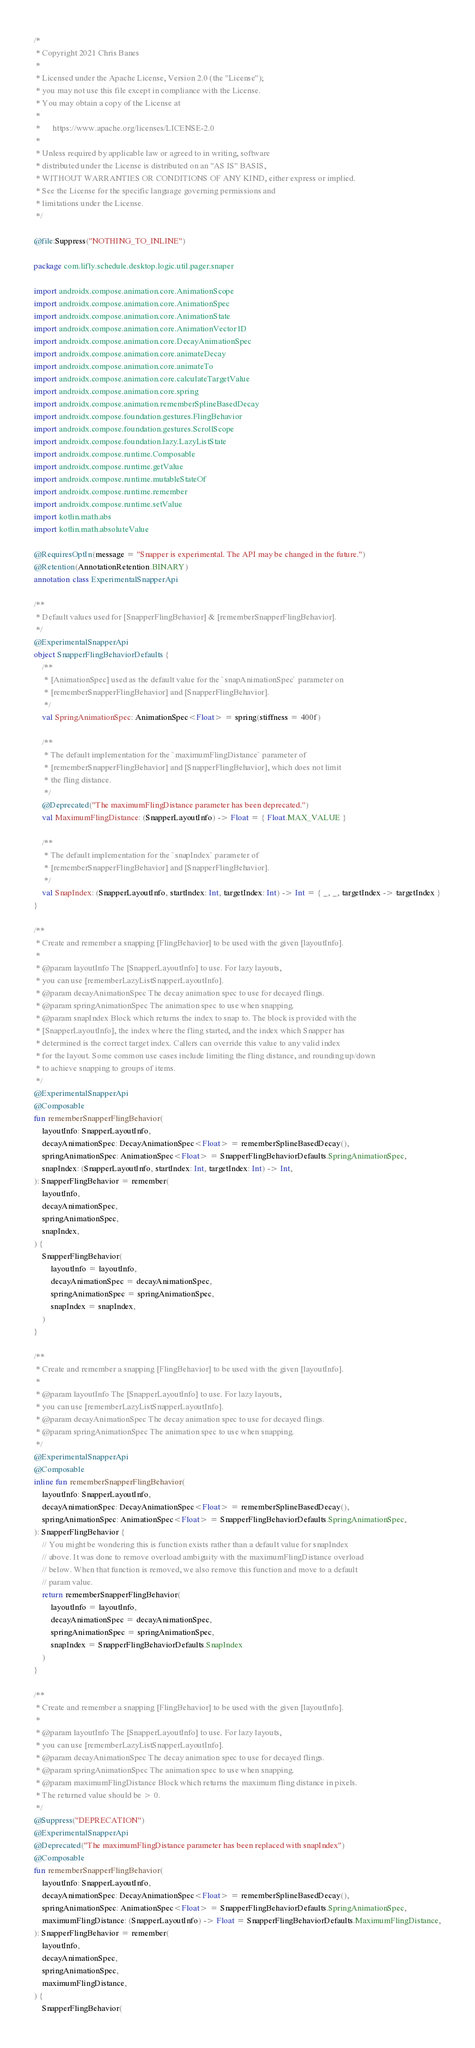Convert code to text. <code><loc_0><loc_0><loc_500><loc_500><_Kotlin_>/*
 * Copyright 2021 Chris Banes
 *
 * Licensed under the Apache License, Version 2.0 (the "License");
 * you may not use this file except in compliance with the License.
 * You may obtain a copy of the License at
 *
 *      https://www.apache.org/licenses/LICENSE-2.0
 *
 * Unless required by applicable law or agreed to in writing, software
 * distributed under the License is distributed on an "AS IS" BASIS,
 * WITHOUT WARRANTIES OR CONDITIONS OF ANY KIND, either express or implied.
 * See the License for the specific language governing permissions and
 * limitations under the License.
 */

@file:Suppress("NOTHING_TO_INLINE")

package com.lifly.schedule.desktop.logic.util.pager.snaper

import androidx.compose.animation.core.AnimationScope
import androidx.compose.animation.core.AnimationSpec
import androidx.compose.animation.core.AnimationState
import androidx.compose.animation.core.AnimationVector1D
import androidx.compose.animation.core.DecayAnimationSpec
import androidx.compose.animation.core.animateDecay
import androidx.compose.animation.core.animateTo
import androidx.compose.animation.core.calculateTargetValue
import androidx.compose.animation.core.spring
import androidx.compose.animation.rememberSplineBasedDecay
import androidx.compose.foundation.gestures.FlingBehavior
import androidx.compose.foundation.gestures.ScrollScope
import androidx.compose.foundation.lazy.LazyListState
import androidx.compose.runtime.Composable
import androidx.compose.runtime.getValue
import androidx.compose.runtime.mutableStateOf
import androidx.compose.runtime.remember
import androidx.compose.runtime.setValue
import kotlin.math.abs
import kotlin.math.absoluteValue

@RequiresOptIn(message = "Snapper is experimental. The API may be changed in the future.")
@Retention(AnnotationRetention.BINARY)
annotation class ExperimentalSnapperApi

/**
 * Default values used for [SnapperFlingBehavior] & [rememberSnapperFlingBehavior].
 */
@ExperimentalSnapperApi
object SnapperFlingBehaviorDefaults {
    /**
     * [AnimationSpec] used as the default value for the `snapAnimationSpec` parameter on
     * [rememberSnapperFlingBehavior] and [SnapperFlingBehavior].
     */
    val SpringAnimationSpec: AnimationSpec<Float> = spring(stiffness = 400f)

    /**
     * The default implementation for the `maximumFlingDistance` parameter of
     * [rememberSnapperFlingBehavior] and [SnapperFlingBehavior], which does not limit
     * the fling distance.
     */
    @Deprecated("The maximumFlingDistance parameter has been deprecated.")
    val MaximumFlingDistance: (SnapperLayoutInfo) -> Float = { Float.MAX_VALUE }

    /**
     * The default implementation for the `snapIndex` parameter of
     * [rememberSnapperFlingBehavior] and [SnapperFlingBehavior].
     */
    val SnapIndex: (SnapperLayoutInfo, startIndex: Int, targetIndex: Int) -> Int = { _, _, targetIndex -> targetIndex }
}

/**
 * Create and remember a snapping [FlingBehavior] to be used with the given [layoutInfo].
 *
 * @param layoutInfo The [SnapperLayoutInfo] to use. For lazy layouts,
 * you can use [rememberLazyListSnapperLayoutInfo].
 * @param decayAnimationSpec The decay animation spec to use for decayed flings.
 * @param springAnimationSpec The animation spec to use when snapping.
 * @param snapIndex Block which returns the index to snap to. The block is provided with the
 * [SnapperLayoutInfo], the index where the fling started, and the index which Snapper has
 * determined is the correct target index. Callers can override this value to any valid index
 * for the layout. Some common use cases include limiting the fling distance, and rounding up/down
 * to achieve snapping to groups of items.
 */
@ExperimentalSnapperApi
@Composable
fun rememberSnapperFlingBehavior(
    layoutInfo: SnapperLayoutInfo,
    decayAnimationSpec: DecayAnimationSpec<Float> = rememberSplineBasedDecay(),
    springAnimationSpec: AnimationSpec<Float> = SnapperFlingBehaviorDefaults.SpringAnimationSpec,
    snapIndex: (SnapperLayoutInfo, startIndex: Int, targetIndex: Int) -> Int,
): SnapperFlingBehavior = remember(
    layoutInfo,
    decayAnimationSpec,
    springAnimationSpec,
    snapIndex,
) {
    SnapperFlingBehavior(
        layoutInfo = layoutInfo,
        decayAnimationSpec = decayAnimationSpec,
        springAnimationSpec = springAnimationSpec,
        snapIndex = snapIndex,
    )
}

/**
 * Create and remember a snapping [FlingBehavior] to be used with the given [layoutInfo].
 *
 * @param layoutInfo The [SnapperLayoutInfo] to use. For lazy layouts,
 * you can use [rememberLazyListSnapperLayoutInfo].
 * @param decayAnimationSpec The decay animation spec to use for decayed flings.
 * @param springAnimationSpec The animation spec to use when snapping.
 */
@ExperimentalSnapperApi
@Composable
inline fun rememberSnapperFlingBehavior(
    layoutInfo: SnapperLayoutInfo,
    decayAnimationSpec: DecayAnimationSpec<Float> = rememberSplineBasedDecay(),
    springAnimationSpec: AnimationSpec<Float> = SnapperFlingBehaviorDefaults.SpringAnimationSpec,
): SnapperFlingBehavior {
    // You might be wondering this is function exists rather than a default value for snapIndex
    // above. It was done to remove overload ambiguity with the maximumFlingDistance overload
    // below. When that function is removed, we also remove this function and move to a default
    // param value.
    return rememberSnapperFlingBehavior(
        layoutInfo = layoutInfo,
        decayAnimationSpec = decayAnimationSpec,
        springAnimationSpec = springAnimationSpec,
        snapIndex = SnapperFlingBehaviorDefaults.SnapIndex
    )
}

/**
 * Create and remember a snapping [FlingBehavior] to be used with the given [layoutInfo].
 *
 * @param layoutInfo The [SnapperLayoutInfo] to use. For lazy layouts,
 * you can use [rememberLazyListSnapperLayoutInfo].
 * @param decayAnimationSpec The decay animation spec to use for decayed flings.
 * @param springAnimationSpec The animation spec to use when snapping.
 * @param maximumFlingDistance Block which returns the maximum fling distance in pixels.
 * The returned value should be > 0.
 */
@Suppress("DEPRECATION")
@ExperimentalSnapperApi
@Deprecated("The maximumFlingDistance parameter has been replaced with snapIndex")
@Composable
fun rememberSnapperFlingBehavior(
    layoutInfo: SnapperLayoutInfo,
    decayAnimationSpec: DecayAnimationSpec<Float> = rememberSplineBasedDecay(),
    springAnimationSpec: AnimationSpec<Float> = SnapperFlingBehaviorDefaults.SpringAnimationSpec,
    maximumFlingDistance: (SnapperLayoutInfo) -> Float = SnapperFlingBehaviorDefaults.MaximumFlingDistance,
): SnapperFlingBehavior = remember(
    layoutInfo,
    decayAnimationSpec,
    springAnimationSpec,
    maximumFlingDistance,
) {
    SnapperFlingBehavior(</code> 